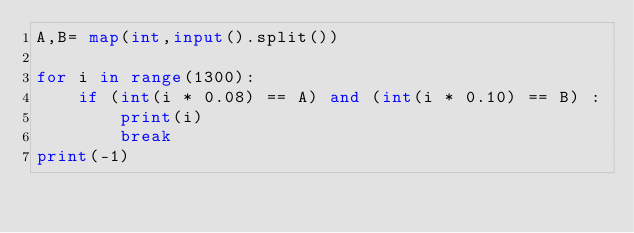Convert code to text. <code><loc_0><loc_0><loc_500><loc_500><_Python_>A,B= map(int,input().split())

for i in range(1300):
    if (int(i * 0.08) == A) and (int(i * 0.10) == B) :
        print(i)
        break
print(-1)</code> 